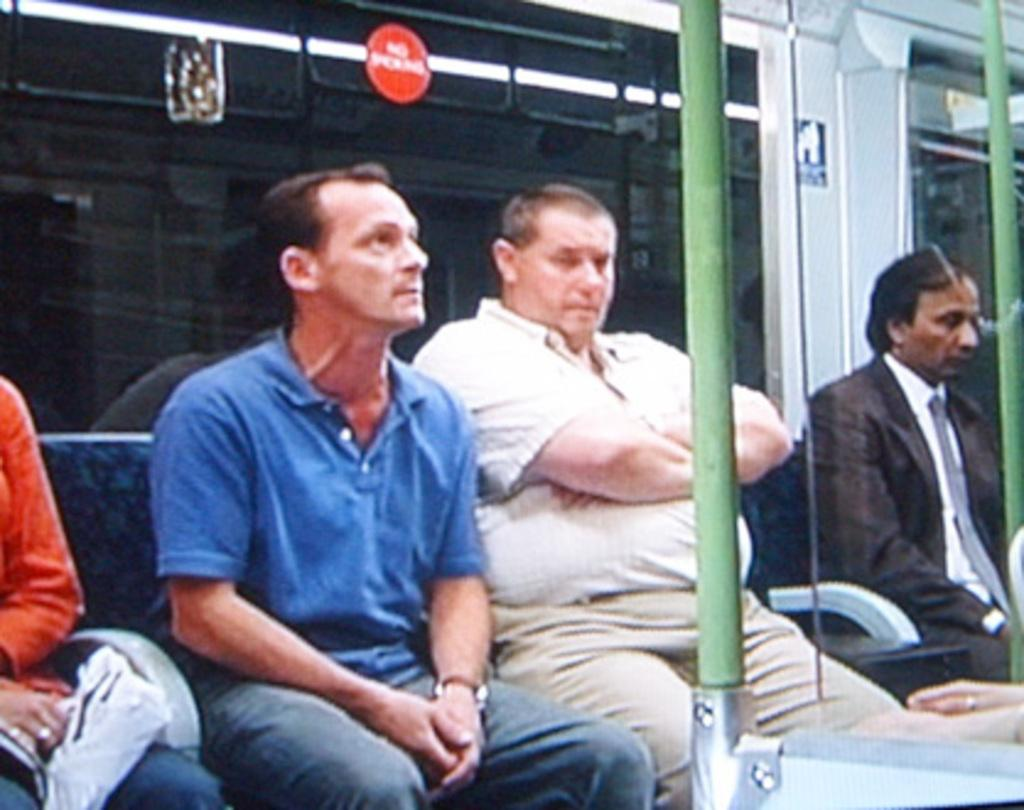What are the people in the image doing? The people in the image are sitting on seats. What can be seen in the image besides the people? There is a pole in the image. What type of apparatus is being used by the people in the image? There is no apparatus visible in the image; the people are simply sitting on seats. Where is the camp located in the image? There is no camp present in the image. 